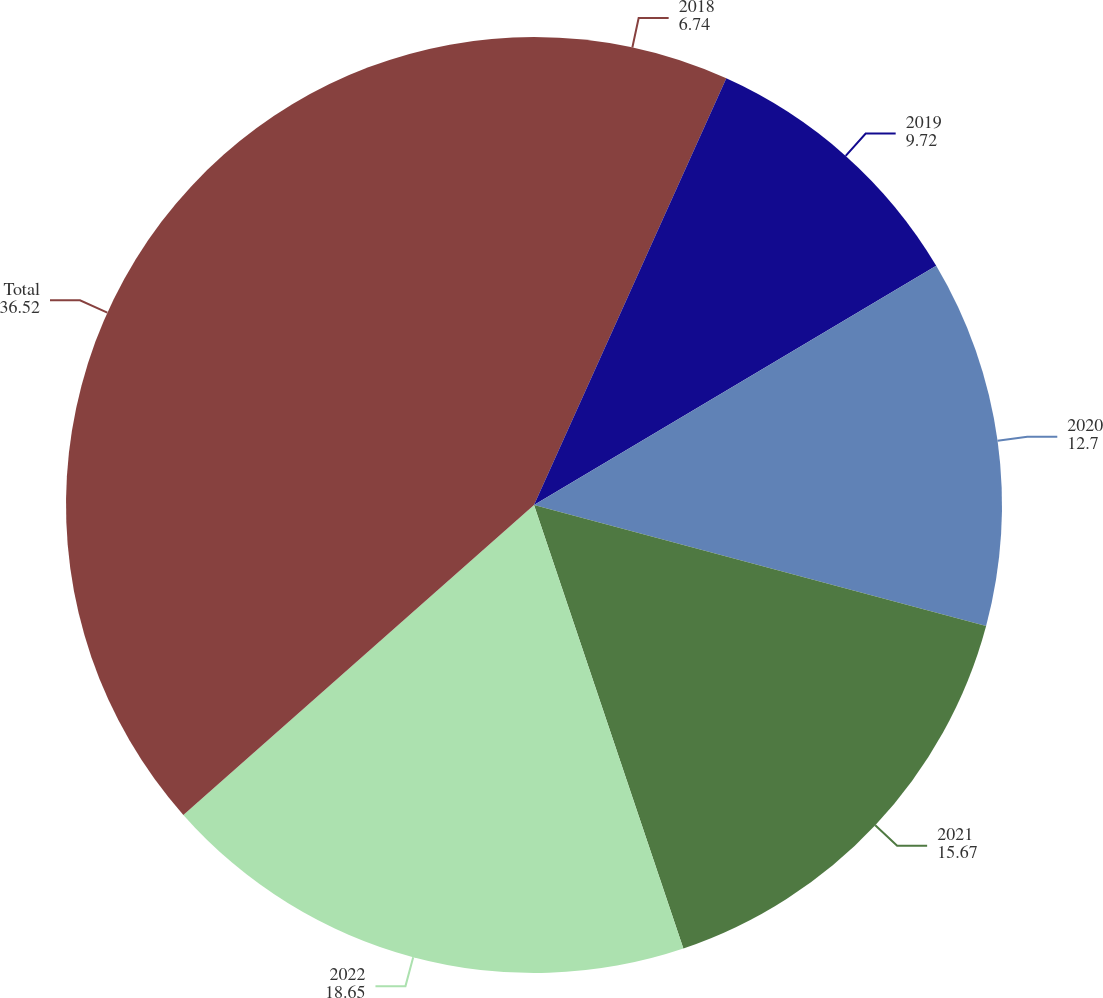<chart> <loc_0><loc_0><loc_500><loc_500><pie_chart><fcel>2018<fcel>2019<fcel>2020<fcel>2021<fcel>2022<fcel>Total<nl><fcel>6.74%<fcel>9.72%<fcel>12.7%<fcel>15.67%<fcel>18.65%<fcel>36.52%<nl></chart> 